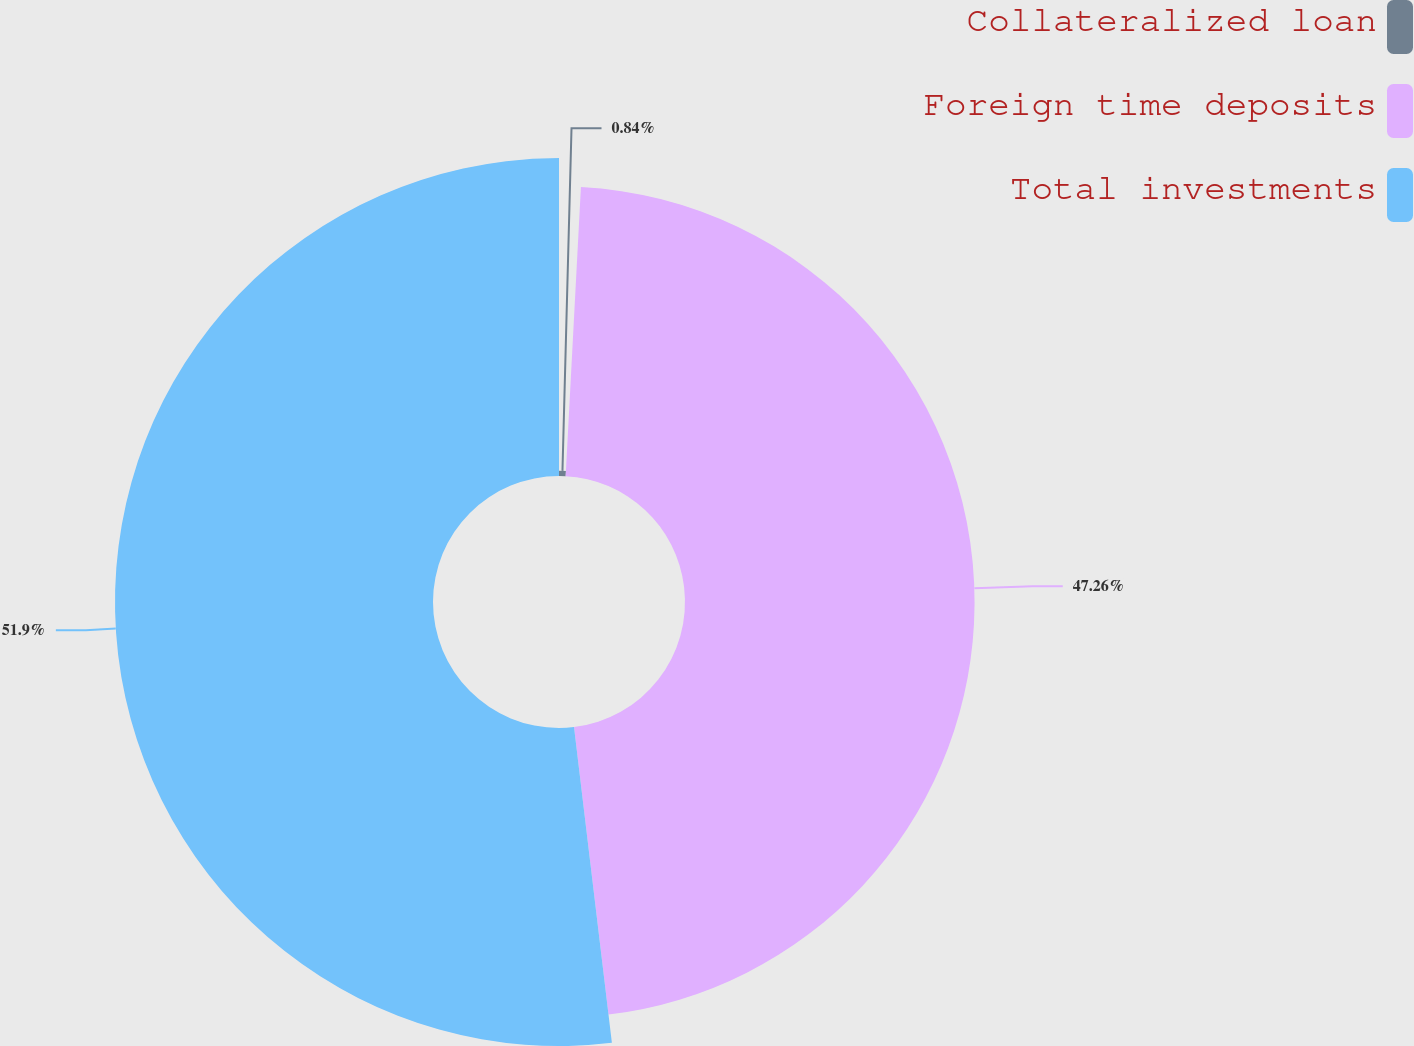<chart> <loc_0><loc_0><loc_500><loc_500><pie_chart><fcel>Collateralized loan<fcel>Foreign time deposits<fcel>Total investments<nl><fcel>0.84%<fcel>47.26%<fcel>51.9%<nl></chart> 